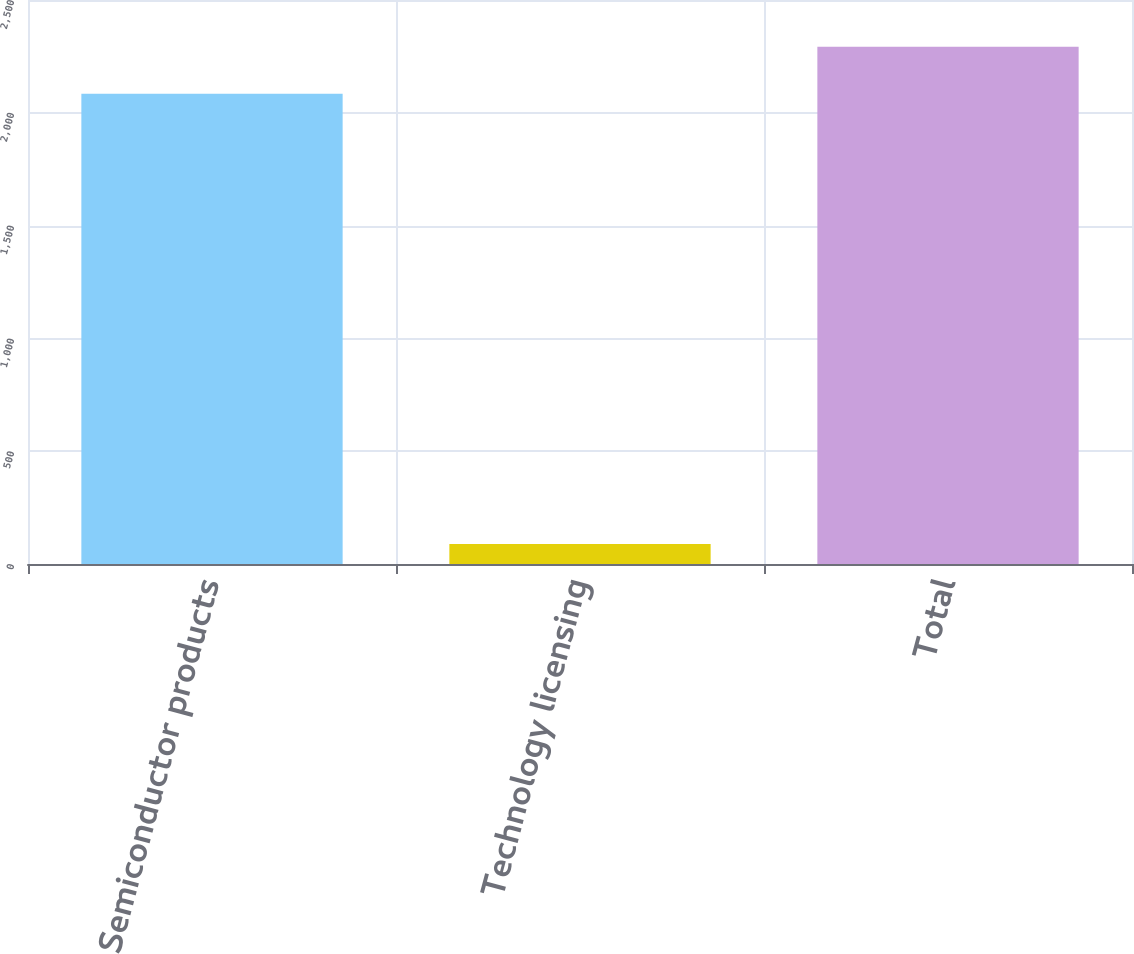<chart> <loc_0><loc_0><loc_500><loc_500><bar_chart><fcel>Semiconductor products<fcel>Technology licensing<fcel>Total<nl><fcel>2084.2<fcel>89.1<fcel>2292.62<nl></chart> 